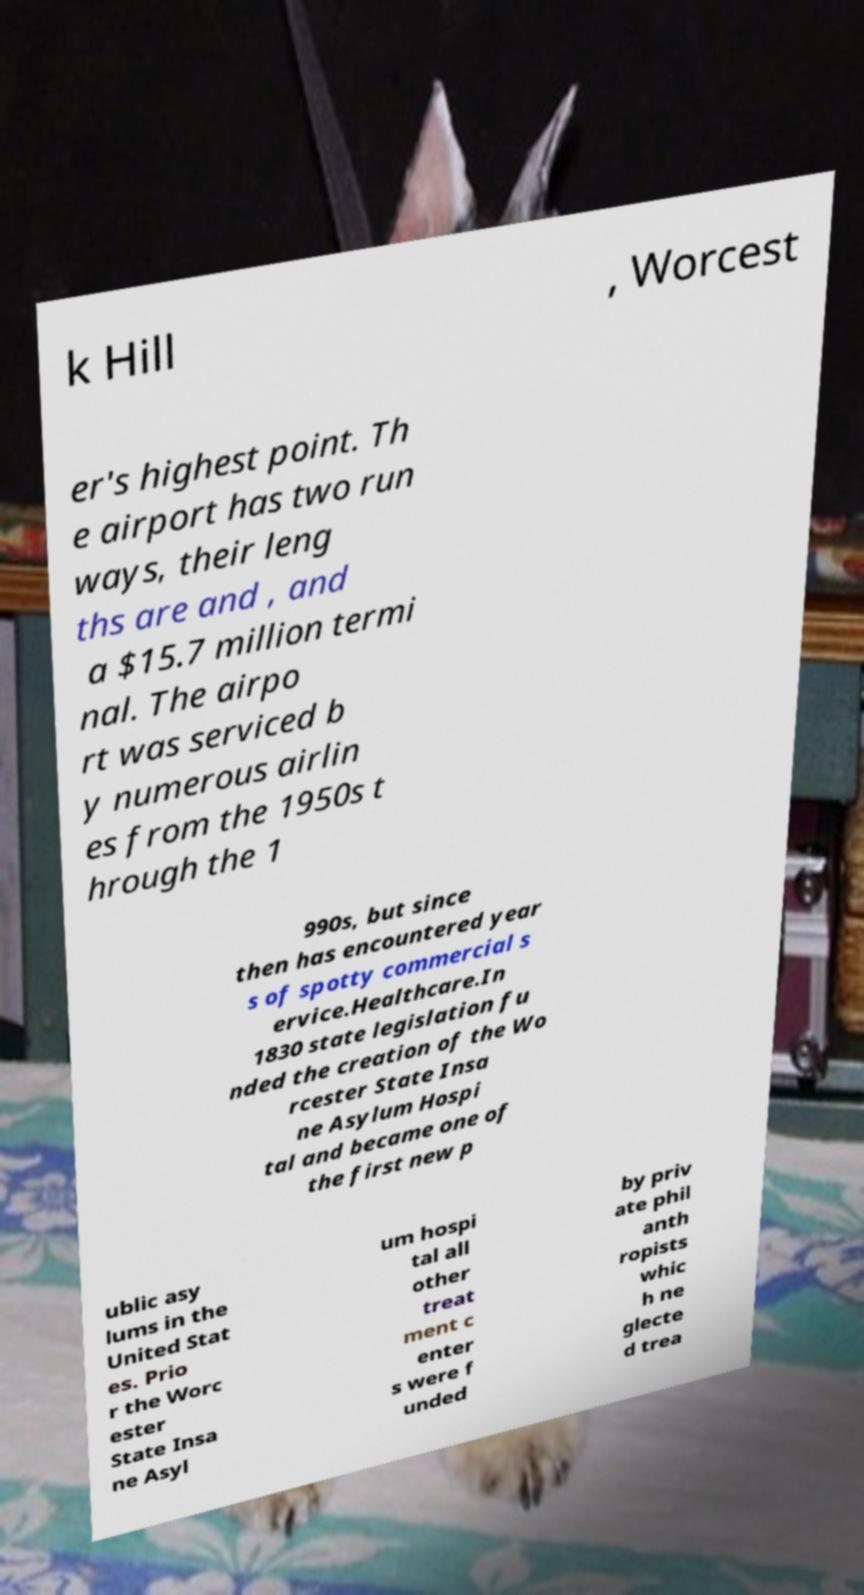What messages or text are displayed in this image? I need them in a readable, typed format. k Hill , Worcest er's highest point. Th e airport has two run ways, their leng ths are and , and a $15.7 million termi nal. The airpo rt was serviced b y numerous airlin es from the 1950s t hrough the 1 990s, but since then has encountered year s of spotty commercial s ervice.Healthcare.In 1830 state legislation fu nded the creation of the Wo rcester State Insa ne Asylum Hospi tal and became one of the first new p ublic asy lums in the United Stat es. Prio r the Worc ester State Insa ne Asyl um hospi tal all other treat ment c enter s were f unded by priv ate phil anth ropists whic h ne glecte d trea 